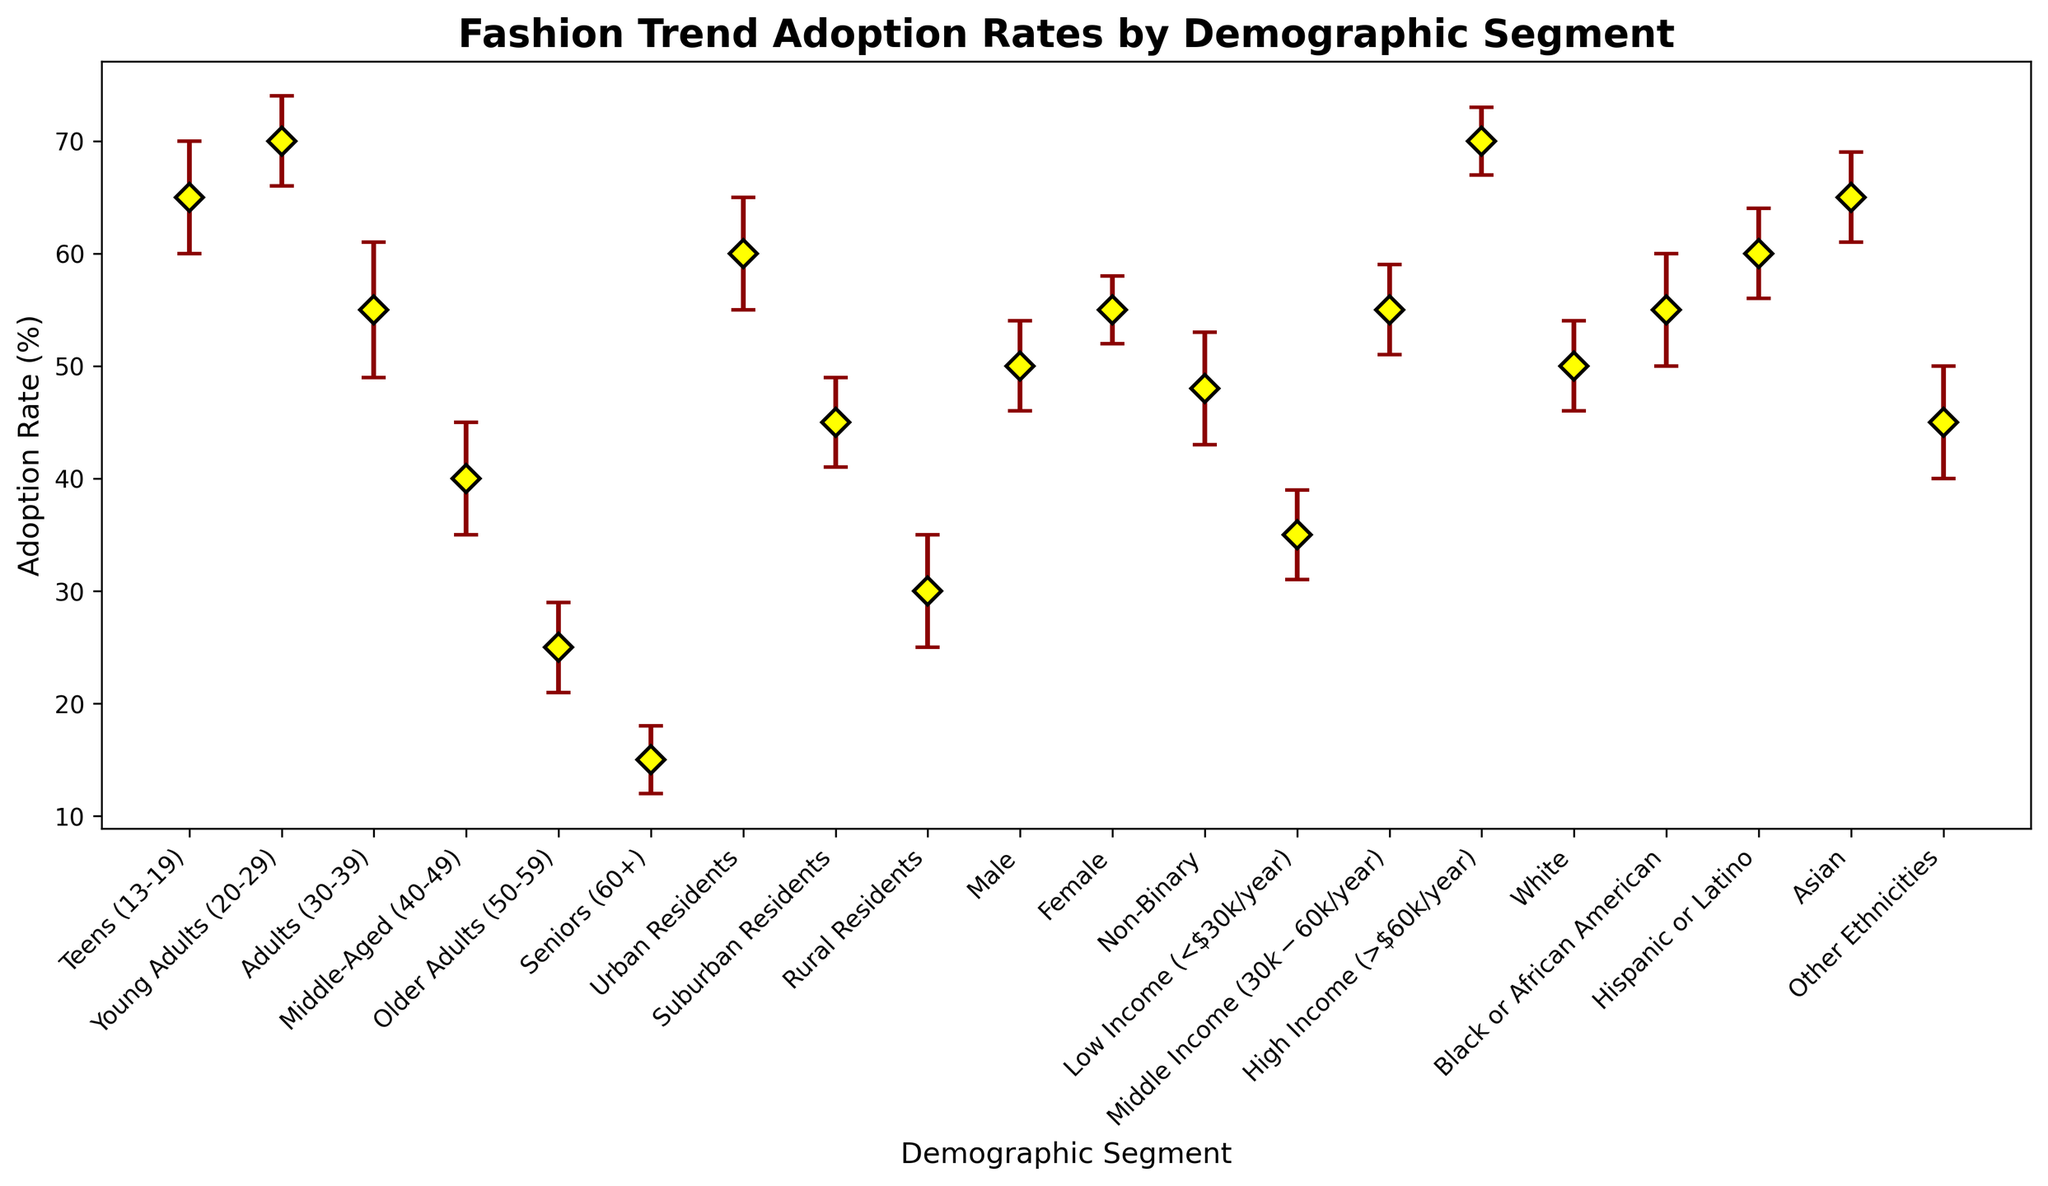How much higher is the adoption rate of fashion trends in Young Adults (20-29) compared to Older Adults (50-59)? The adoption rate for Young Adults (20-29) is 70%, and for Older Adults (50-59) is 25%. The difference is 70% - 25% = 45%.
Answer: 45% Which demographic segment has the highest adoption rate, and what is the rate? Looking at the y-axis and error bars, the highest point is for Young Adults (20-29), with an adoption rate of 70%.
Answer: Young Adults (20-29), 70% Considering the error estimates, which demographic segment has the most uncertain adoption rate? The segment with the highest error estimate has the most uncertainty. Middle-Aged (40-49) and Other Ethnicities, both have an error estimate of 5%.
Answer: Middle-Aged (40-49) and Other Ethnicities What is the average adoption rate of fashion trends for the segments aged 30-39 and below (Teens (13-19), Young Adults (20-29), Adults (30-39))? The adoption rates are 65% for Teens (13-19), 70% for Young Adults (20-29), and 55% for Adults (30-39). The average is (65 + 70 + 55) / 3 = 190 / 3 ≈ 63.33
Answer: ≈ 63.33% Compare the adoption rates of Urban Residents and Rural Residents. Which segment has a higher rate and by how much? Urban Residents have a rate of 60%, and Rural Residents have a rate of 30%. The difference is 60% - 30% = 30%.
Answer: Urban Residents, 30% Which gender has the higher adoption rate, and what is the difference between them? Women have an adoption rate of 55%, while Men have a rate of 50%. The difference is 55% - 50% = 5%.
Answer: Female, 5% What is the overall trend in adoption rates from lower to higher income groups? The adoption rates increase from 35% for Low Income, 55% for Middle Income, to 70% for High Income.
Answer: Increasing Calculate the difference in adoption rates between the highest and lowest segments for any demographic characteristic. The highest adoption rate is for Young Adults (20-29) at 70%, and the lowest is for Seniors (60+) at 15%. The difference is 70% - 15% = 55%.
Answer: 55% How does the adoption rate compare between Hispanic or Latino and Other Ethnicities? Hispanic or Latino has an adoption rate of 60%, while Other Ethnicities have a rate of 45%. The difference is 60% - 45% = 15%.
Answer: Hispanic or Latino, 15% What is the impact of error estimates on the adoption rate for Teens (13-19) and how can this influence our interpretation? Teens (13-19) have an adoption rate of 65% with an error estimate of 5%. This means the adoption rate could realistically vary between 60% to 70%, showing a potential variance that could impact exact interpretations.
Answer: 65% ± 5% 